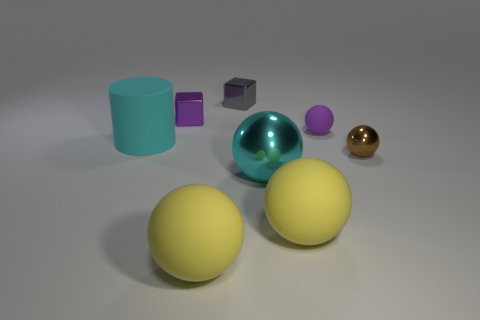There is a brown sphere that is behind the big cyan ball to the right of the cyan cylinder that is on the left side of the tiny brown ball; how big is it?
Keep it short and to the point. Small. There is a big yellow thing on the right side of the big shiny object; are there any tiny brown metallic things that are in front of it?
Offer a terse response. No. What number of balls are behind the small shiny object that is right of the purple rubber ball that is to the left of the brown object?
Your answer should be compact. 1. What color is the metal thing that is both to the left of the brown metallic sphere and in front of the purple sphere?
Provide a short and direct response. Cyan. How many tiny objects have the same color as the large metal object?
Offer a terse response. 0. What number of spheres are either metal objects or rubber objects?
Give a very brief answer. 5. There is a matte ball that is the same size as the purple metallic thing; what is its color?
Give a very brief answer. Purple. There is a small shiny object that is in front of the rubber sphere that is behind the large cyan matte thing; are there any spheres to the left of it?
Ensure brevity in your answer.  Yes. What is the size of the gray shiny cube?
Provide a succinct answer. Small. What number of objects are either tiny red metallic cylinders or large yellow matte spheres?
Make the answer very short. 2. 